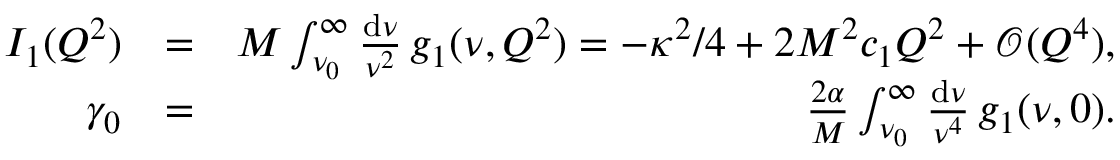<formula> <loc_0><loc_0><loc_500><loc_500>\begin{array} { r l r } { I _ { 1 } ( Q ^ { 2 } ) } & { = } & { M \int _ { \nu _ { 0 } } ^ { \infty } \frac { d \nu } { \nu ^ { 2 } } \, g _ { 1 } ( \nu , Q ^ { 2 } ) = - \kappa ^ { 2 } / 4 + 2 M ^ { 2 } c _ { 1 } Q ^ { 2 } + \mathcal { O } ( Q ^ { 4 } ) , } \\ { \gamma _ { 0 } } & { = } & { \frac { 2 \alpha } { M } \int _ { \nu _ { 0 } } ^ { \infty } \frac { d \nu } { \nu ^ { 4 } } \, g _ { 1 } ( \nu , 0 ) . } \end{array}</formula> 